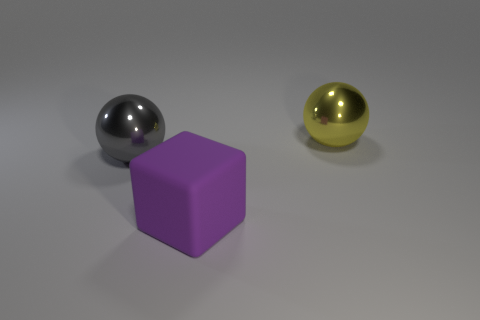Add 3 metallic spheres. How many objects exist? 6 Subtract all blocks. How many objects are left? 2 Subtract 0 blue spheres. How many objects are left? 3 Subtract all tiny red matte cubes. Subtract all big gray balls. How many objects are left? 2 Add 3 big yellow things. How many big yellow things are left? 4 Add 1 purple things. How many purple things exist? 2 